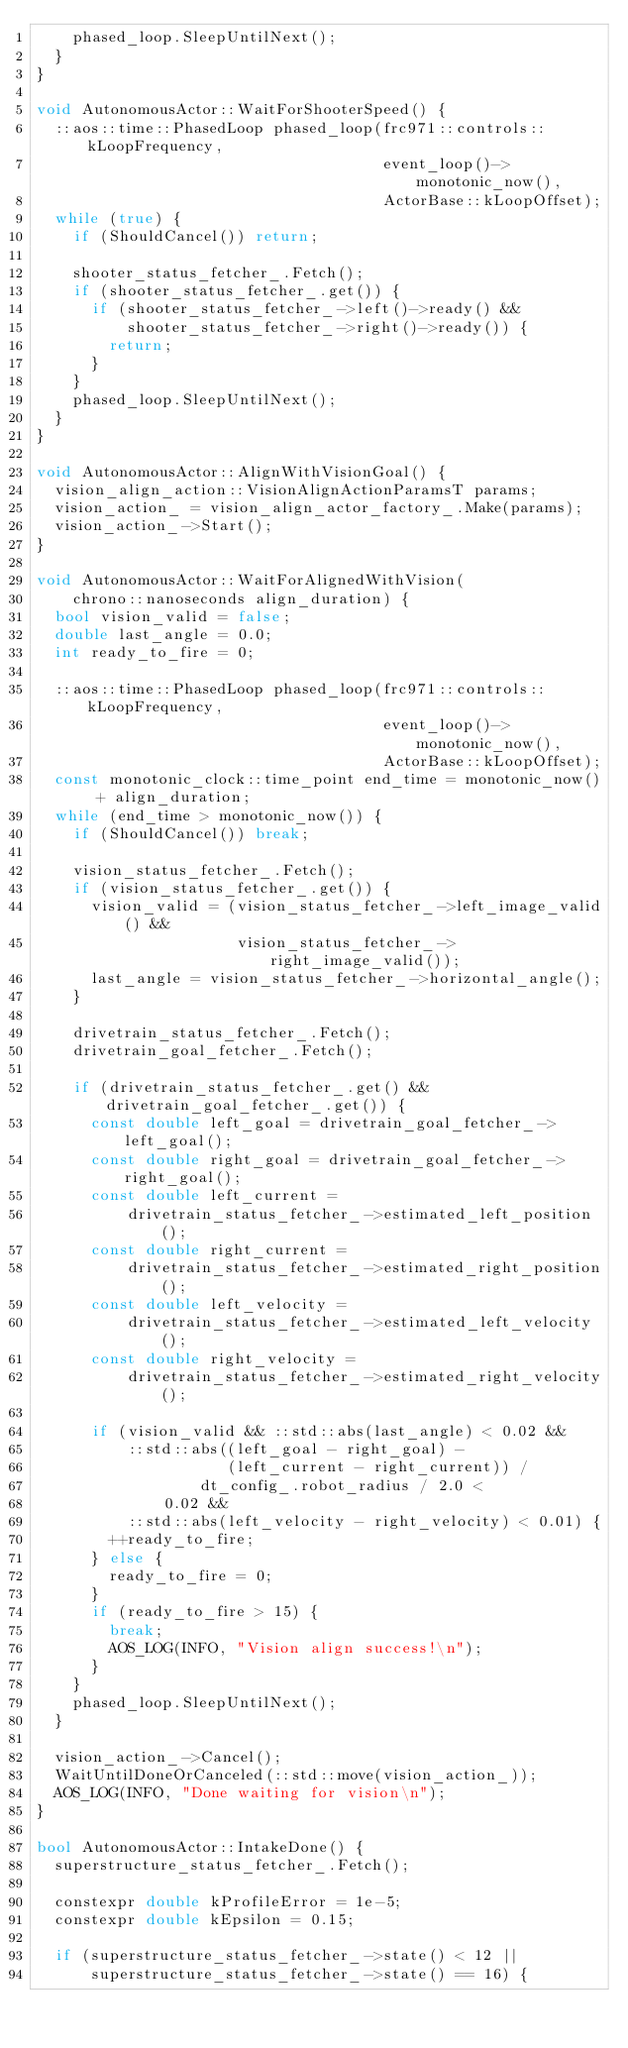Convert code to text. <code><loc_0><loc_0><loc_500><loc_500><_C++_>    phased_loop.SleepUntilNext();
  }
}

void AutonomousActor::WaitForShooterSpeed() {
  ::aos::time::PhasedLoop phased_loop(frc971::controls::kLoopFrequency,
                                      event_loop()->monotonic_now(),
                                      ActorBase::kLoopOffset);
  while (true) {
    if (ShouldCancel()) return;

    shooter_status_fetcher_.Fetch();
    if (shooter_status_fetcher_.get()) {
      if (shooter_status_fetcher_->left()->ready() &&
          shooter_status_fetcher_->right()->ready()) {
        return;
      }
    }
    phased_loop.SleepUntilNext();
  }
}

void AutonomousActor::AlignWithVisionGoal() {
  vision_align_action::VisionAlignActionParamsT params;
  vision_action_ = vision_align_actor_factory_.Make(params);
  vision_action_->Start();
}

void AutonomousActor::WaitForAlignedWithVision(
    chrono::nanoseconds align_duration) {
  bool vision_valid = false;
  double last_angle = 0.0;
  int ready_to_fire = 0;

  ::aos::time::PhasedLoop phased_loop(frc971::controls::kLoopFrequency,
                                      event_loop()->monotonic_now(),
                                      ActorBase::kLoopOffset);
  const monotonic_clock::time_point end_time = monotonic_now() + align_duration;
  while (end_time > monotonic_now()) {
    if (ShouldCancel()) break;

    vision_status_fetcher_.Fetch();
    if (vision_status_fetcher_.get()) {
      vision_valid = (vision_status_fetcher_->left_image_valid() &&
                      vision_status_fetcher_->right_image_valid());
      last_angle = vision_status_fetcher_->horizontal_angle();
    }

    drivetrain_status_fetcher_.Fetch();
    drivetrain_goal_fetcher_.Fetch();

    if (drivetrain_status_fetcher_.get() && drivetrain_goal_fetcher_.get()) {
      const double left_goal = drivetrain_goal_fetcher_->left_goal();
      const double right_goal = drivetrain_goal_fetcher_->right_goal();
      const double left_current =
          drivetrain_status_fetcher_->estimated_left_position();
      const double right_current =
          drivetrain_status_fetcher_->estimated_right_position();
      const double left_velocity =
          drivetrain_status_fetcher_->estimated_left_velocity();
      const double right_velocity =
          drivetrain_status_fetcher_->estimated_right_velocity();

      if (vision_valid && ::std::abs(last_angle) < 0.02 &&
          ::std::abs((left_goal - right_goal) -
                     (left_current - right_current)) /
                  dt_config_.robot_radius / 2.0 <
              0.02 &&
          ::std::abs(left_velocity - right_velocity) < 0.01) {
        ++ready_to_fire;
      } else {
        ready_to_fire = 0;
      }
      if (ready_to_fire > 15) {
        break;
        AOS_LOG(INFO, "Vision align success!\n");
      }
    }
    phased_loop.SleepUntilNext();
  }

  vision_action_->Cancel();
  WaitUntilDoneOrCanceled(::std::move(vision_action_));
  AOS_LOG(INFO, "Done waiting for vision\n");
}

bool AutonomousActor::IntakeDone() {
  superstructure_status_fetcher_.Fetch();

  constexpr double kProfileError = 1e-5;
  constexpr double kEpsilon = 0.15;

  if (superstructure_status_fetcher_->state() < 12 ||
      superstructure_status_fetcher_->state() == 16) {</code> 